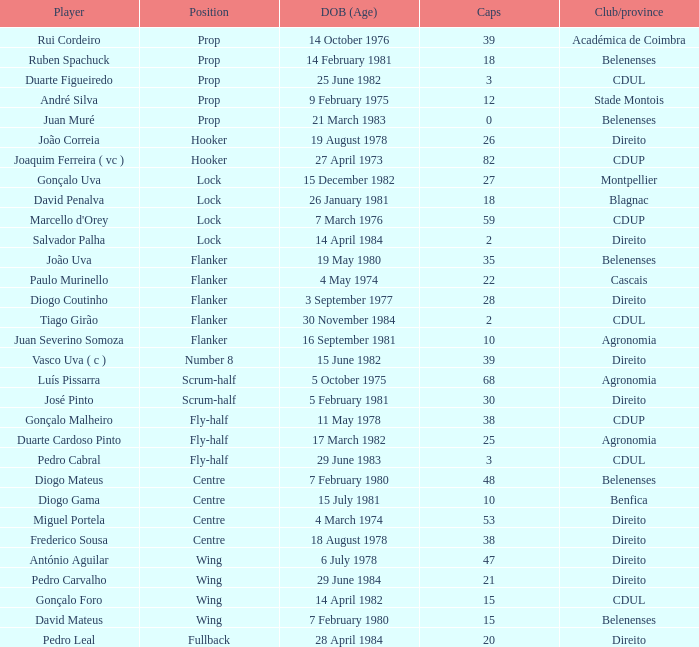Which Club/province has a Player of david penalva? Blagnac. 